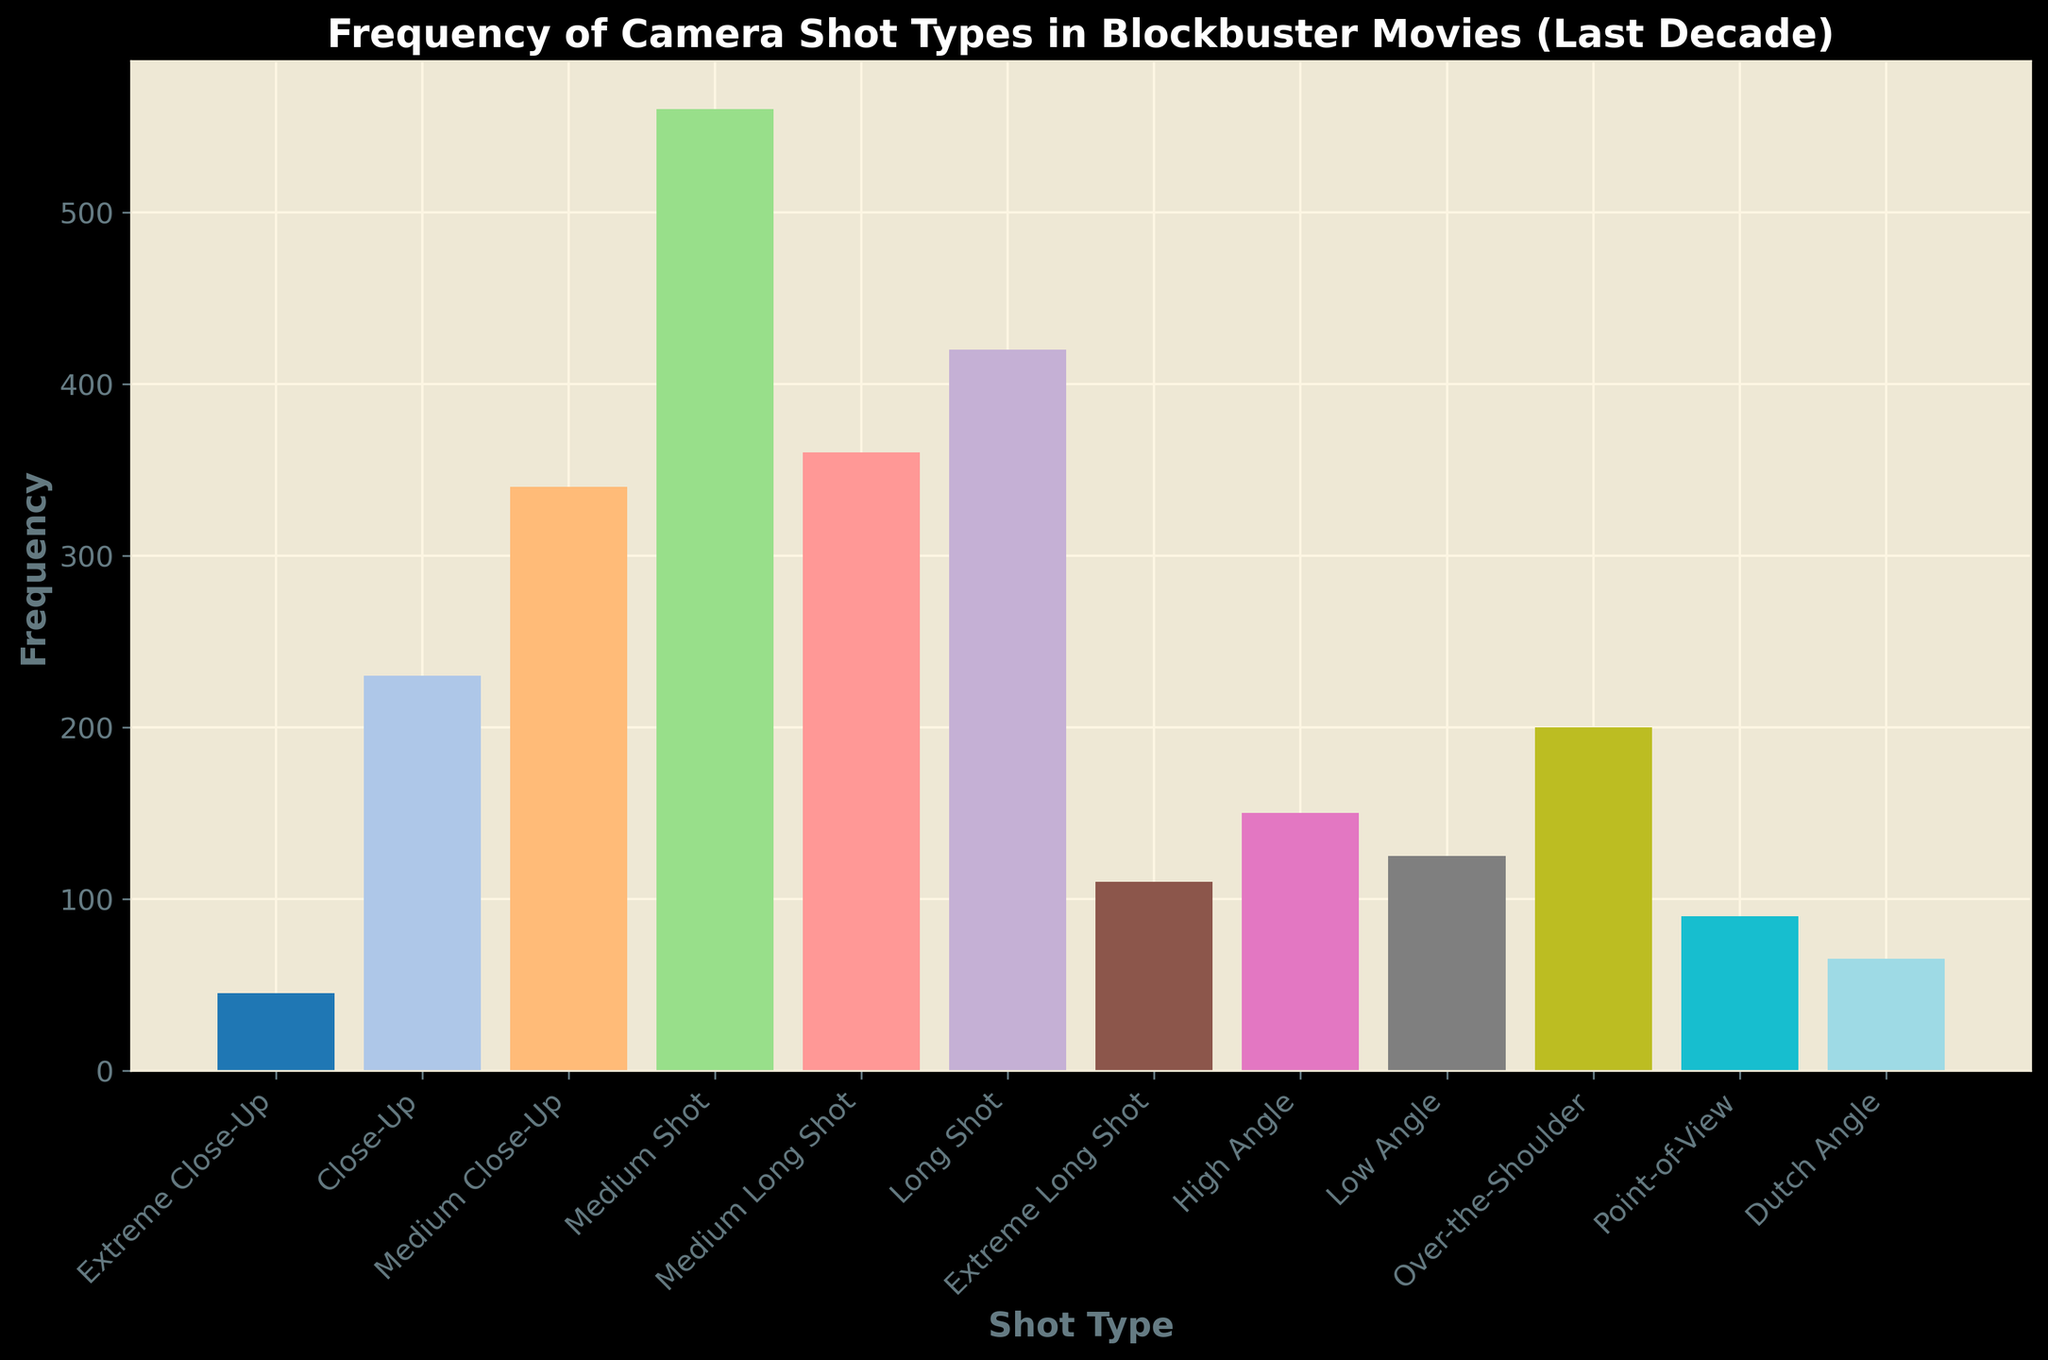What's the most frequently used camera shot type in blockbuster movies over the last decade? The tallest bar in the histogram represents the most frequently used camera shot type. The tallest bar is for the Medium Shot with a frequency of 560.
Answer: Medium Shot Which camera shot type has the lowest frequency of use, and what is that frequency? The shortest bar in the histogram represents the camera shot type with the lowest frequency. The shortest bar is for the Extreme Close-Up with a frequency of 45.
Answer: Extreme Close-Up, 45 How do the frequencies of Close-Up and Over-the-Shoulder compare? The bar for Close-Up has a height of 230, while the bar for Over-the-Shoulder has a height of 200. The Close-Up frequency is higher than the Over-the-Shoulder frequency.
Answer: Close-Up is higher What's the combined frequency of Medium Long Shot, Long Shot, and Extreme Long Shot? Adding up the frequencies: Medium Long Shot (360) + Long Shot (420) + Extreme Long Shot (110) = 360 + 420 + 110 = 890.
Answer: 890 Are there more high-angle shots or low-angle shots used in blockbuster movies, and by how much? Comparing the heights of the bars, the High Angle has a frequency of 150 and the Low Angle has a frequency of 125. The difference is 150 - 125 = 25.
Answer: High Angle, by 25 What's the average frequency of the three most frequently used camera shot types? The three most frequently used camera shot types are Medium Shot (560), Medium Close-Up (340), and Long Shot (420). The average frequency is (560 + 340 + 420) / 3 = 1320 / 3 = 440.
Answer: 440 Which camera shot types have frequencies between 100 and 200, inclusive? Identifying the bars within the range of 100 to 200: High Angle (150), Low Angle (125), Over-the-Shoulder (200), Point-of-View (90), and Dutch Angle (65). Filtering those within the range 100-200: High Angle (150), Low Angle (125), and Over-the-Shoulder (200).
Answer: High Angle, Low Angle, Over-the-Shoulder What's the median frequency value of all the camera shot types? Sorting the frequencies: 45, 65, 90, 110, 125, 150, 200, 230, 340, 360, 420, 560. With 12 values, the median is the average of the 6th and 7th values: (150 + 200) / 2 = 350 / 2 = 175.
Answer: 175 How does the frequency of Dutch Angle compare visually to Point-of-View? The bar for Point-of-View is higher than the bar for Dutch Angle. The Point-of-View bar has a frequency of 90, while the Dutch Angle has a frequency of 65.
Answer: Point-of-View is higher What is the total frequency of all camera shot types combined? Summing up all the frequencies: 45 + 230 + 340 + 560 + 360 + 420 + 110 + 150 + 125 + 200 + 90 + 65 = 2695.
Answer: 2695 